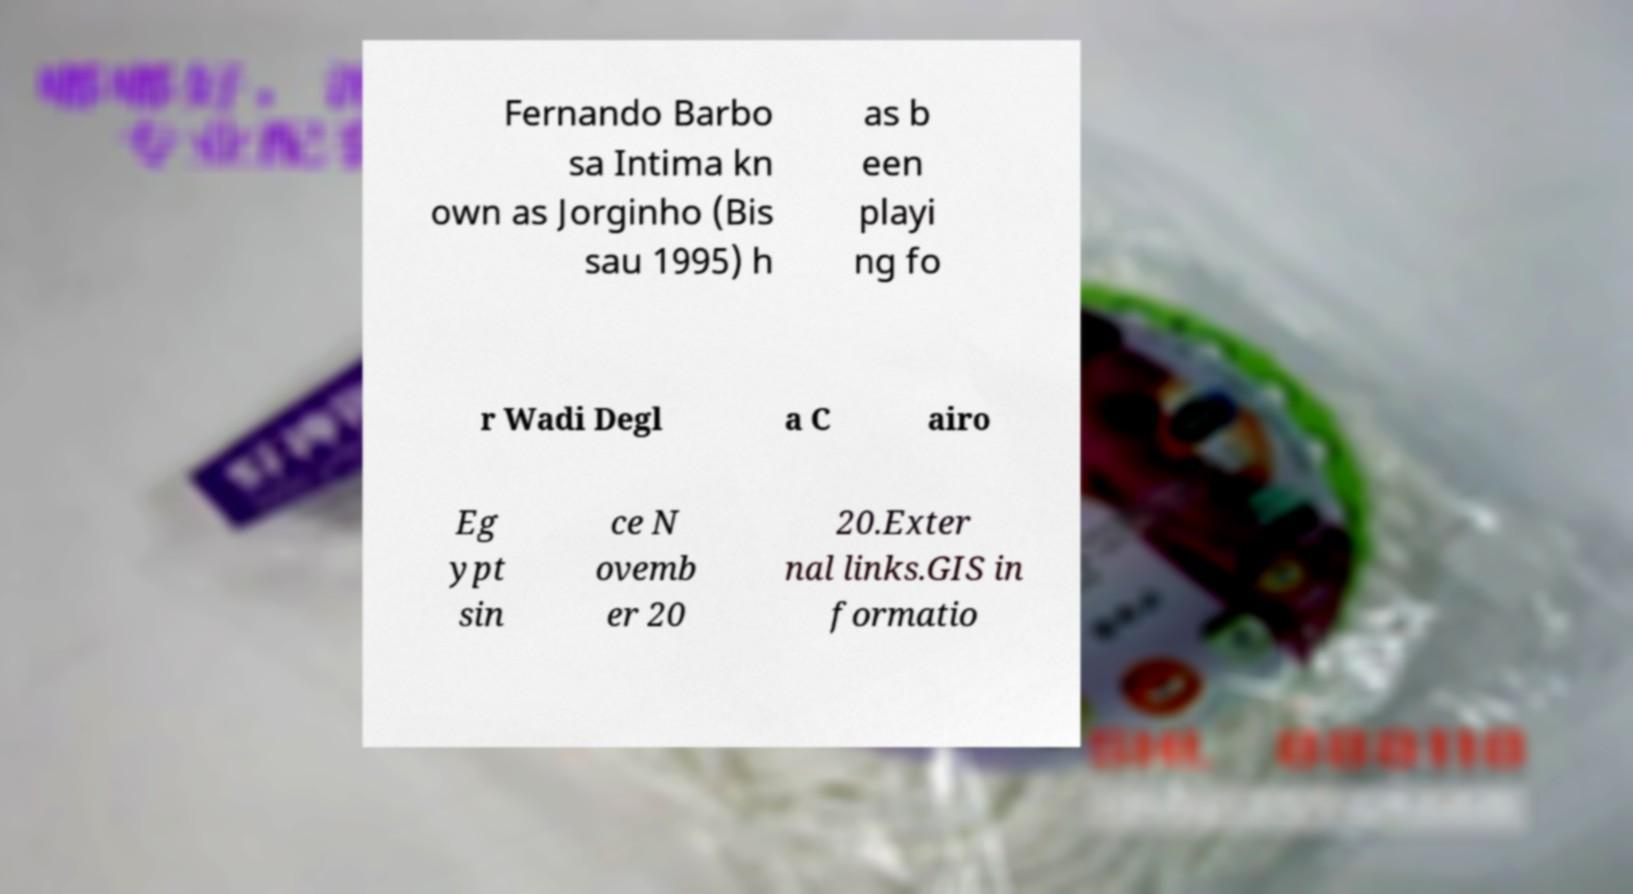Could you extract and type out the text from this image? Fernando Barbo sa Intima kn own as Jorginho (Bis sau 1995) h as b een playi ng fo r Wadi Degl a C airo Eg ypt sin ce N ovemb er 20 20.Exter nal links.GIS in formatio 